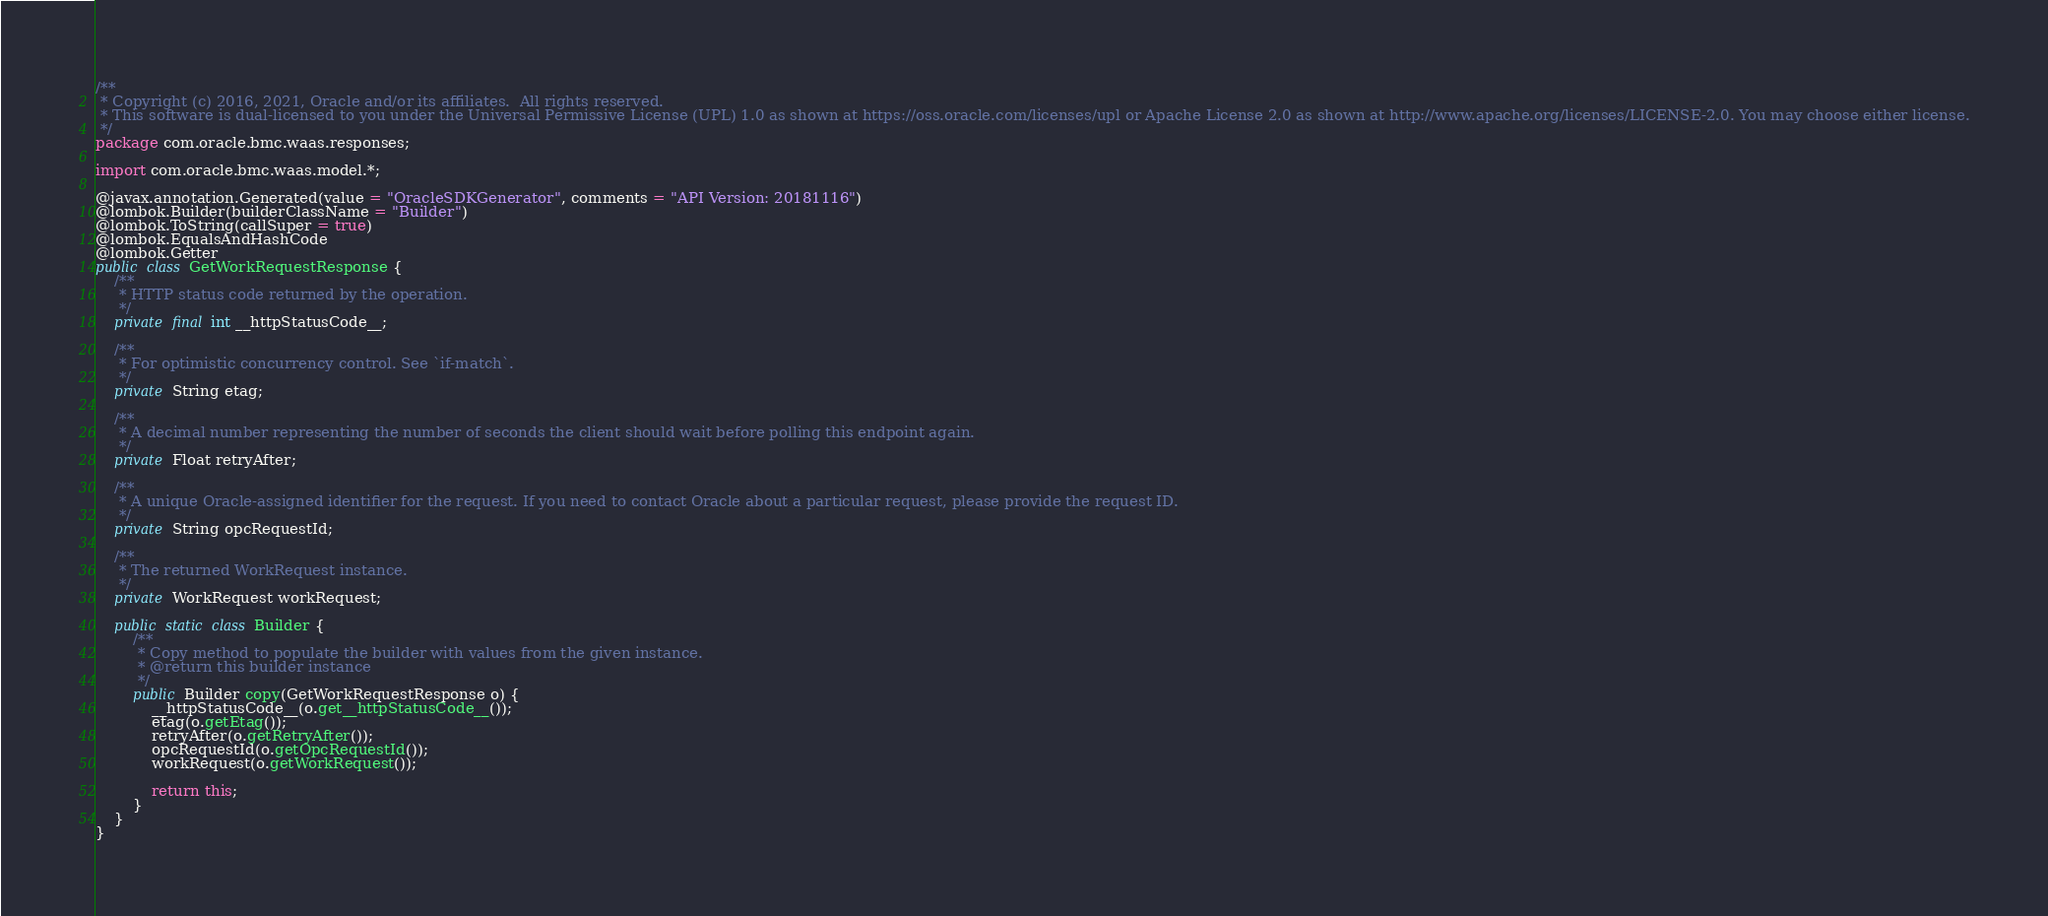Convert code to text. <code><loc_0><loc_0><loc_500><loc_500><_Java_>/**
 * Copyright (c) 2016, 2021, Oracle and/or its affiliates.  All rights reserved.
 * This software is dual-licensed to you under the Universal Permissive License (UPL) 1.0 as shown at https://oss.oracle.com/licenses/upl or Apache License 2.0 as shown at http://www.apache.org/licenses/LICENSE-2.0. You may choose either license.
 */
package com.oracle.bmc.waas.responses;

import com.oracle.bmc.waas.model.*;

@javax.annotation.Generated(value = "OracleSDKGenerator", comments = "API Version: 20181116")
@lombok.Builder(builderClassName = "Builder")
@lombok.ToString(callSuper = true)
@lombok.EqualsAndHashCode
@lombok.Getter
public class GetWorkRequestResponse {
    /**
     * HTTP status code returned by the operation.
     */
    private final int __httpStatusCode__;

    /**
     * For optimistic concurrency control. See `if-match`.
     */
    private String etag;

    /**
     * A decimal number representing the number of seconds the client should wait before polling this endpoint again.
     */
    private Float retryAfter;

    /**
     * A unique Oracle-assigned identifier for the request. If you need to contact Oracle about a particular request, please provide the request ID.
     */
    private String opcRequestId;

    /**
     * The returned WorkRequest instance.
     */
    private WorkRequest workRequest;

    public static class Builder {
        /**
         * Copy method to populate the builder with values from the given instance.
         * @return this builder instance
         */
        public Builder copy(GetWorkRequestResponse o) {
            __httpStatusCode__(o.get__httpStatusCode__());
            etag(o.getEtag());
            retryAfter(o.getRetryAfter());
            opcRequestId(o.getOpcRequestId());
            workRequest(o.getWorkRequest());

            return this;
        }
    }
}
</code> 